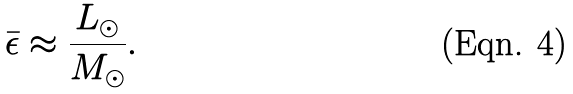Convert formula to latex. <formula><loc_0><loc_0><loc_500><loc_500>\bar { \epsilon } \approx \frac { L _ { \odot } } { M _ { \odot } } .</formula> 